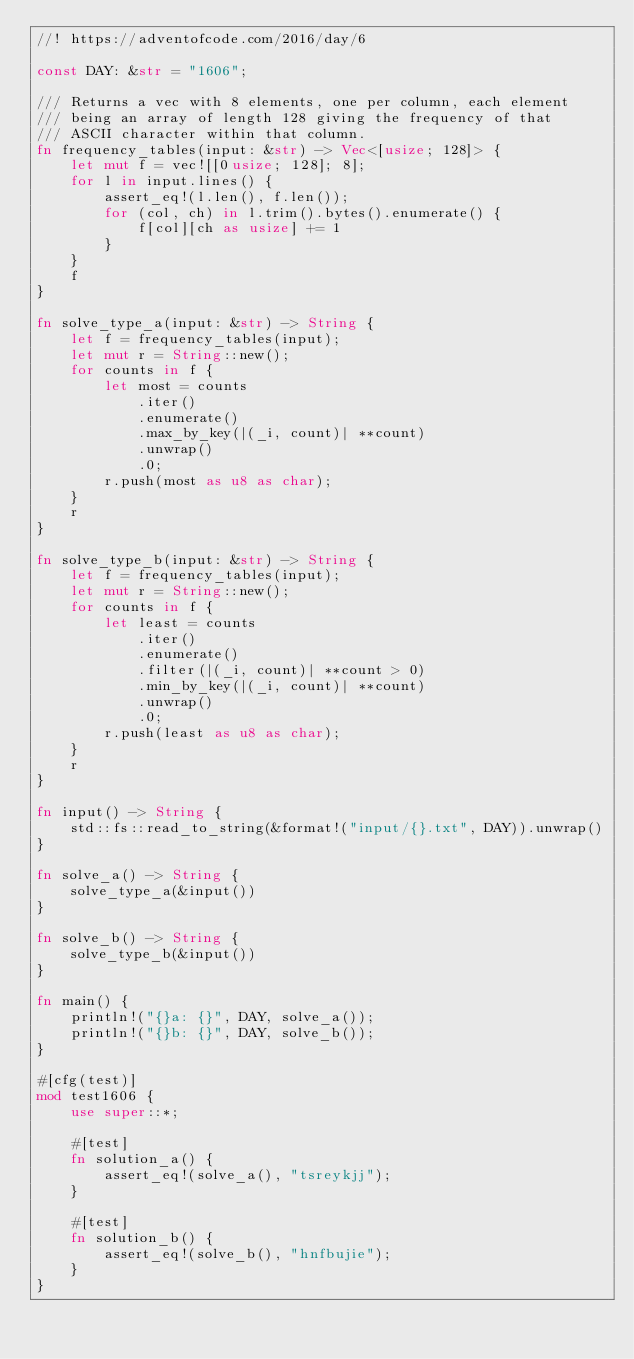<code> <loc_0><loc_0><loc_500><loc_500><_Rust_>//! https://adventofcode.com/2016/day/6

const DAY: &str = "1606";

/// Returns a vec with 8 elements, one per column, each element
/// being an array of length 128 giving the frequency of that
/// ASCII character within that column.
fn frequency_tables(input: &str) -> Vec<[usize; 128]> {
    let mut f = vec![[0usize; 128]; 8];
    for l in input.lines() {
        assert_eq!(l.len(), f.len());
        for (col, ch) in l.trim().bytes().enumerate() {
            f[col][ch as usize] += 1
        }
    }
    f
}

fn solve_type_a(input: &str) -> String {
    let f = frequency_tables(input);
    let mut r = String::new();
    for counts in f {
        let most = counts
            .iter()
            .enumerate()
            .max_by_key(|(_i, count)| **count)
            .unwrap()
            .0;
        r.push(most as u8 as char);
    }
    r
}

fn solve_type_b(input: &str) -> String {
    let f = frequency_tables(input);
    let mut r = String::new();
    for counts in f {
        let least = counts
            .iter()
            .enumerate()
            .filter(|(_i, count)| **count > 0)
            .min_by_key(|(_i, count)| **count)
            .unwrap()
            .0;
        r.push(least as u8 as char);
    }
    r
}

fn input() -> String {
    std::fs::read_to_string(&format!("input/{}.txt", DAY)).unwrap()
}

fn solve_a() -> String {
    solve_type_a(&input())
}

fn solve_b() -> String {
    solve_type_b(&input())
}

fn main() {
    println!("{}a: {}", DAY, solve_a());
    println!("{}b: {}", DAY, solve_b());
}

#[cfg(test)]
mod test1606 {
    use super::*;

    #[test]
    fn solution_a() {
        assert_eq!(solve_a(), "tsreykjj");
    }

    #[test]
    fn solution_b() {
        assert_eq!(solve_b(), "hnfbujie");
    }
}
</code> 